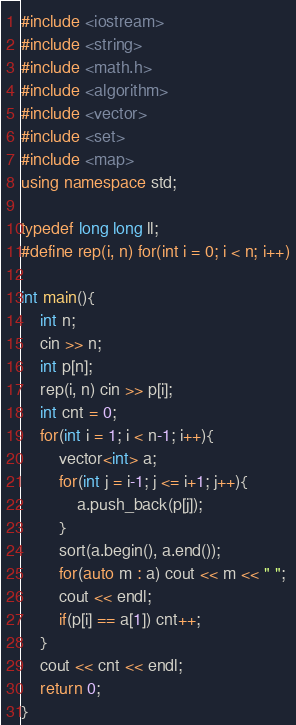Convert code to text. <code><loc_0><loc_0><loc_500><loc_500><_C++_>#include <iostream>
#include <string>
#include <math.h>
#include <algorithm>
#include <vector>
#include <set>
#include <map>
using namespace std;

typedef long long ll;
#define rep(i, n) for(int i = 0; i < n; i++)

int main(){
    int n;
    cin >> n;
    int p[n];
    rep(i, n) cin >> p[i];
    int cnt = 0;
    for(int i = 1; i < n-1; i++){
        vector<int> a;
        for(int j = i-1; j <= i+1; j++){
            a.push_back(p[j]);
        }
        sort(a.begin(), a.end());
        for(auto m : a) cout << m << " ";
        cout << endl;
        if(p[i] == a[1]) cnt++;
    }
    cout << cnt << endl;
    return 0;
}</code> 